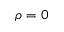Convert formula to latex. <formula><loc_0><loc_0><loc_500><loc_500>\rho = 0</formula> 